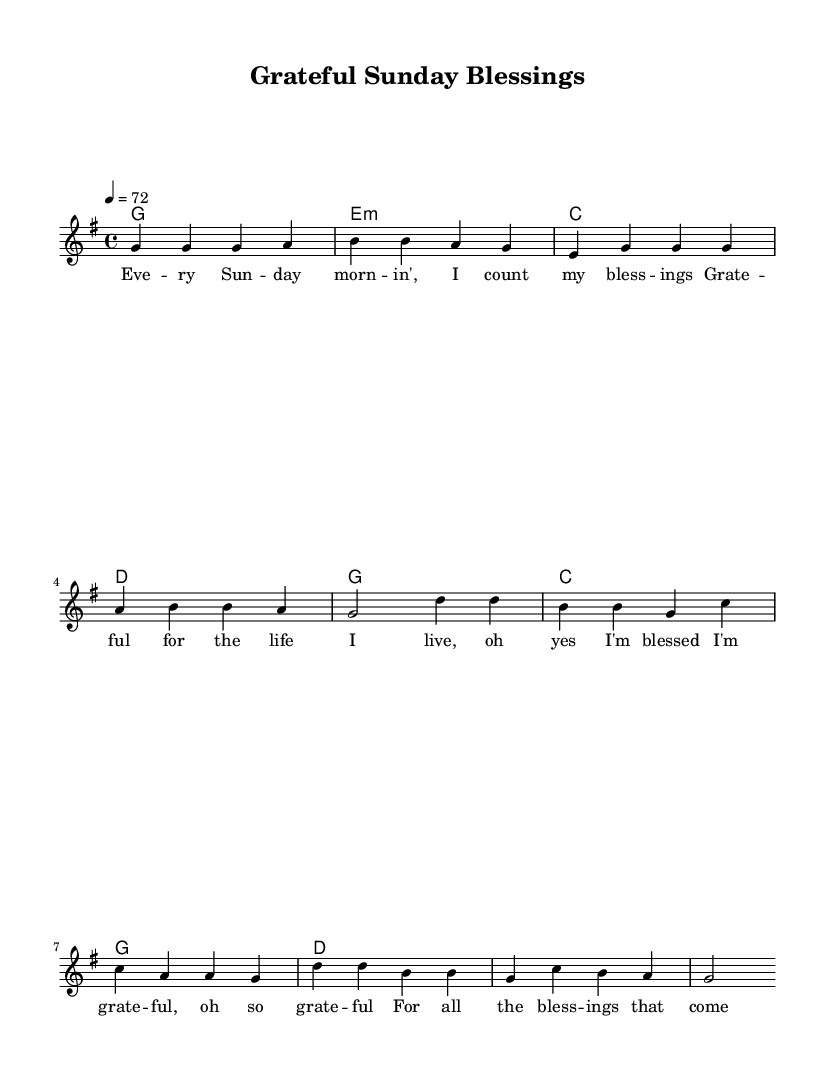What is the key signature of this music? The key signature is G major, which has one sharp (F#). This can be deduced from the global section of the code where the key is indicated.
Answer: G major What is the time signature of this music? The time signature is 4/4, which means there are four beats in each measure and each quarter note gets one beat. This is specified in the global section as well.
Answer: 4/4 What is the tempo marking of this piece? The tempo marking is 4 = 72, indicating that the quarter note should be played at a speed of 72 beats per minute. This is noted in the global section of the music.
Answer: 72 How many measures are in the verse? There are four measures in the verse, as there are four distinct groupings of notes that are separated by vertical lines. This is visible in the melody section where the verse is defined.
Answer: 4 What is the primary theme expressed in the lyrics? The lyrics express gratitude for blessings received, focusing on appreciation for life and positivity. This can be inferred from the content of the verse words provided in the lyrics section.
Answer: Gratitude What type of harmony is used throughout the piece? The harmony consists of triadic chords typical of reggae, with each chord represented in whole notes. This is as seen in the harmonies section of the score.
Answer: Triadic chords How does the chorus differ from the verse in terms of melody? The chorus features a change in melody by utilizing different note sequences and a shift from the verse melody, which is clearly structured but varies in rhythm and pitch. Analyzing the melody shows distinct patterns in each section.
Answer: Different melody 